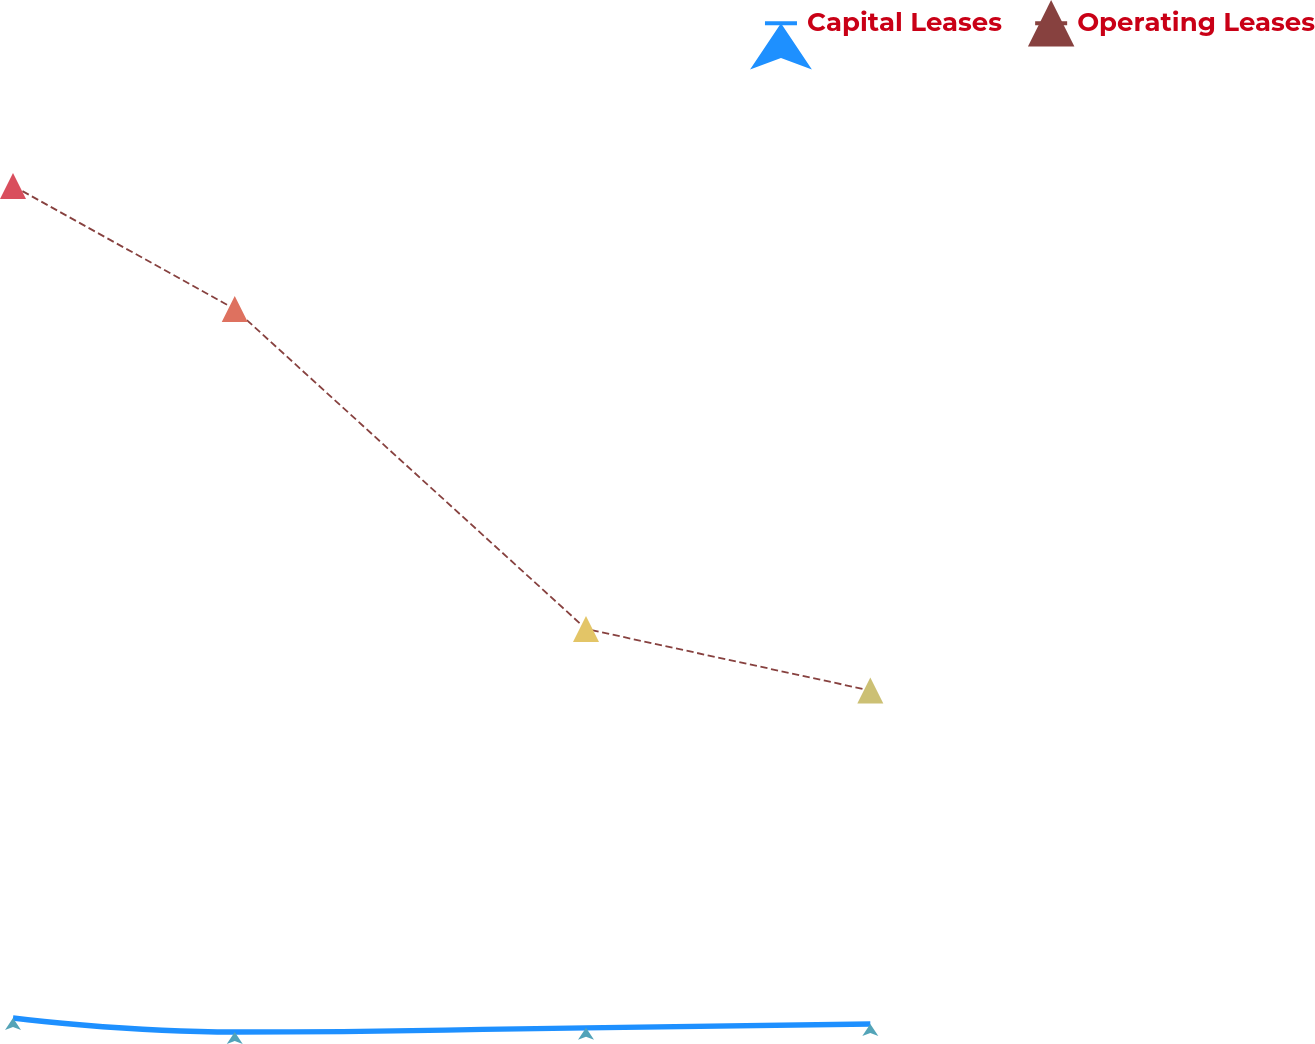<chart> <loc_0><loc_0><loc_500><loc_500><line_chart><ecel><fcel>Capital Leases<fcel>Operating Leases<nl><fcel>1676.13<fcel>3789.28<fcel>64464.6<nl><fcel>1781.7<fcel>2766.94<fcel>55484.6<nl><fcel>1948.94<fcel>3072.31<fcel>32161.2<nl><fcel>2084.3<fcel>3353.29<fcel>27670.2<nl><fcel>2285.54<fcel>3693.4<fcel>19554.2<nl></chart> 